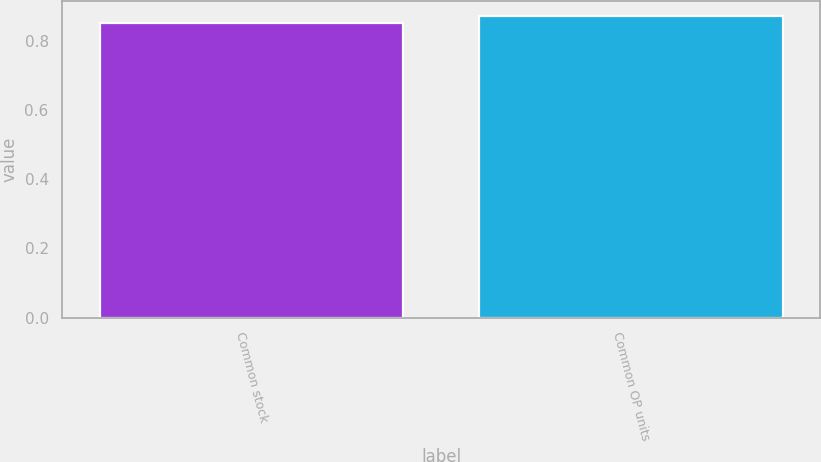Convert chart. <chart><loc_0><loc_0><loc_500><loc_500><bar_chart><fcel>Common stock<fcel>Common OP units<nl><fcel>0.85<fcel>0.87<nl></chart> 